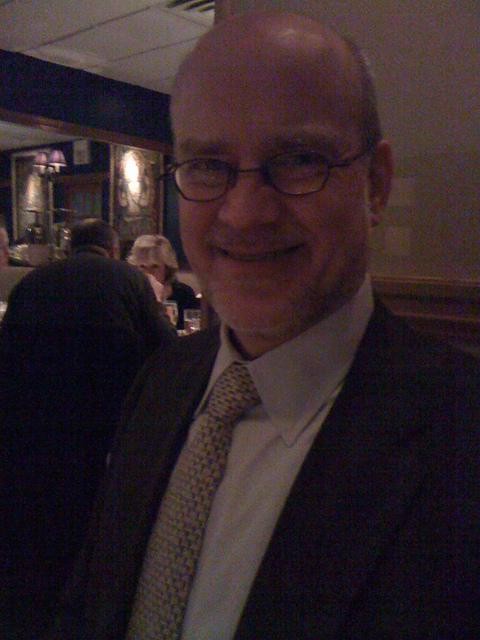What venue is the man in? restaurant 